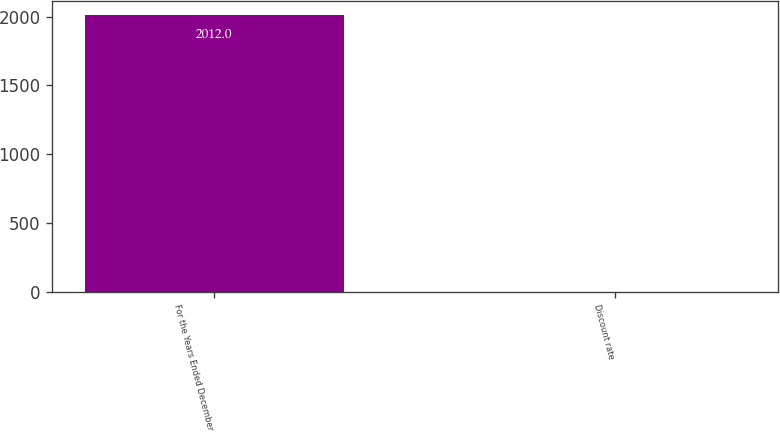Convert chart. <chart><loc_0><loc_0><loc_500><loc_500><bar_chart><fcel>For the Years Ended December<fcel>Discount rate<nl><fcel>2012<fcel>2.15<nl></chart> 